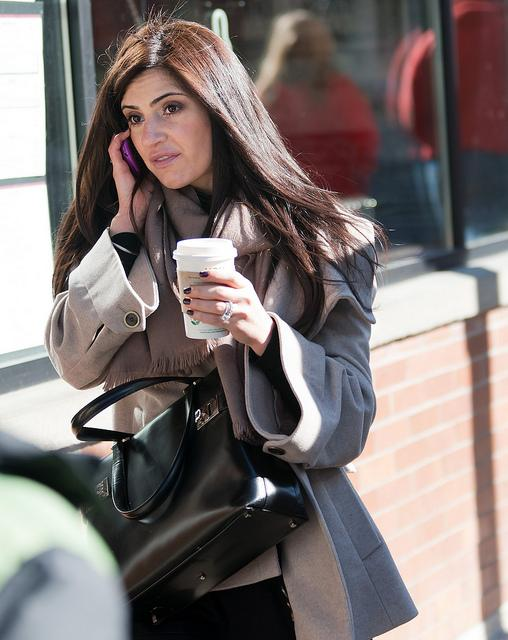What pick me up is found in this woman's cup? coffee 